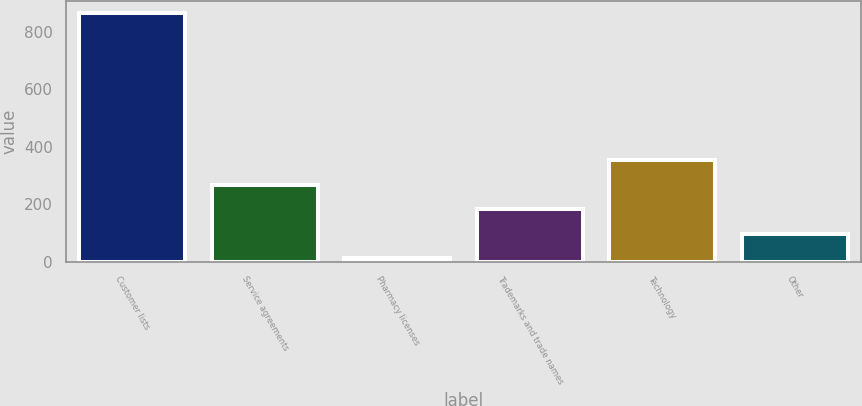<chart> <loc_0><loc_0><loc_500><loc_500><bar_chart><fcel>Customer lists<fcel>Service agreements<fcel>Pharmacy licenses<fcel>Trademarks and trade names<fcel>Technology<fcel>Other<nl><fcel>863<fcel>266.6<fcel>11<fcel>181.4<fcel>351.8<fcel>96.2<nl></chart> 